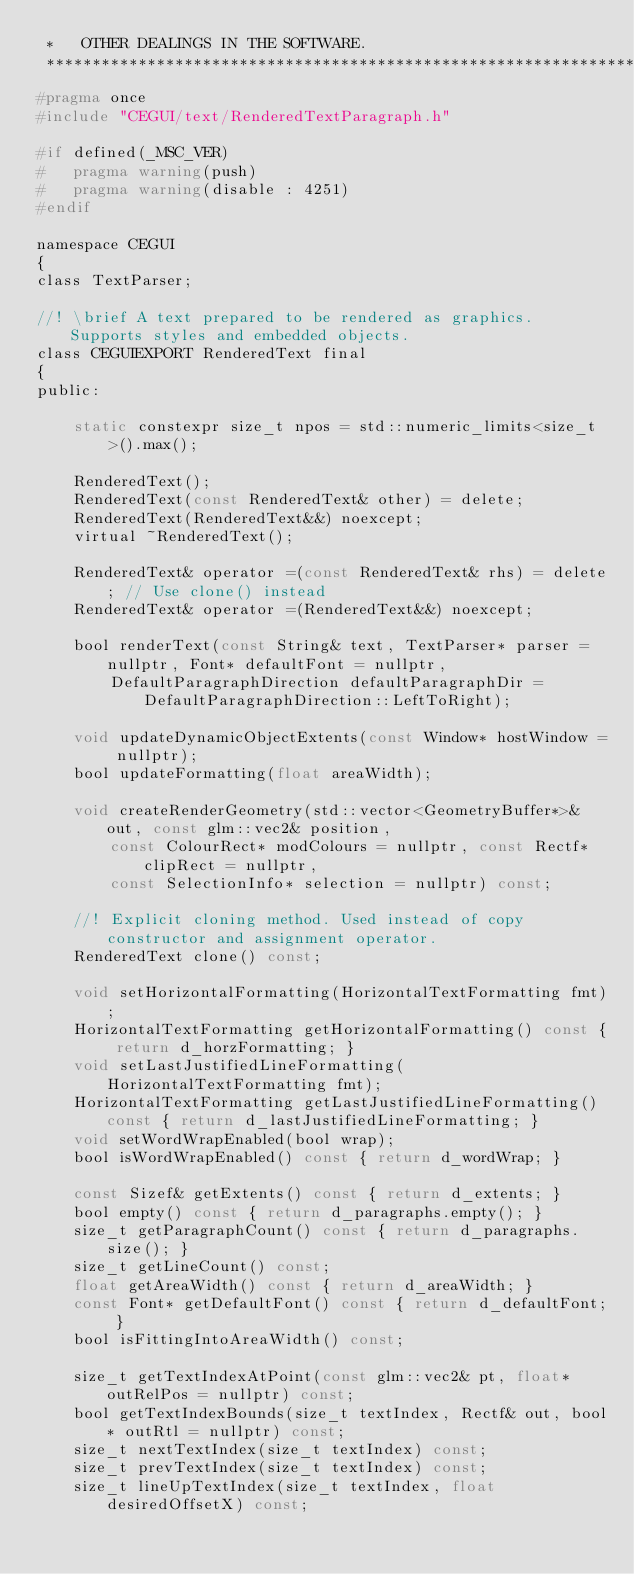<code> <loc_0><loc_0><loc_500><loc_500><_C_> *   OTHER DEALINGS IN THE SOFTWARE.
 ***************************************************************************/
#pragma once
#include "CEGUI/text/RenderedTextParagraph.h"

#if defined(_MSC_VER)
#   pragma warning(push)
#   pragma warning(disable : 4251)
#endif

namespace CEGUI
{
class TextParser;

//! \brief A text prepared to be rendered as graphics. Supports styles and embedded objects.
class CEGUIEXPORT RenderedText final
{
public:

    static constexpr size_t npos = std::numeric_limits<size_t>().max();

    RenderedText();
    RenderedText(const RenderedText& other) = delete;
    RenderedText(RenderedText&&) noexcept;
    virtual ~RenderedText();

    RenderedText& operator =(const RenderedText& rhs) = delete; // Use clone() instead
    RenderedText& operator =(RenderedText&&) noexcept;

    bool renderText(const String& text, TextParser* parser = nullptr, Font* defaultFont = nullptr,
        DefaultParagraphDirection defaultParagraphDir = DefaultParagraphDirection::LeftToRight);

    void updateDynamicObjectExtents(const Window* hostWindow = nullptr);
    bool updateFormatting(float areaWidth);

    void createRenderGeometry(std::vector<GeometryBuffer*>& out, const glm::vec2& position,
        const ColourRect* modColours = nullptr, const Rectf* clipRect = nullptr,
        const SelectionInfo* selection = nullptr) const;

    //! Explicit cloning method. Used instead of copy constructor and assignment operator.
    RenderedText clone() const;

    void setHorizontalFormatting(HorizontalTextFormatting fmt);
    HorizontalTextFormatting getHorizontalFormatting() const { return d_horzFormatting; }
    void setLastJustifiedLineFormatting(HorizontalTextFormatting fmt);
    HorizontalTextFormatting getLastJustifiedLineFormatting() const { return d_lastJustifiedLineFormatting; }
    void setWordWrapEnabled(bool wrap);
    bool isWordWrapEnabled() const { return d_wordWrap; }

    const Sizef& getExtents() const { return d_extents; }
    bool empty() const { return d_paragraphs.empty(); }
    size_t getParagraphCount() const { return d_paragraphs.size(); }
    size_t getLineCount() const;
    float getAreaWidth() const { return d_areaWidth; }
    const Font* getDefaultFont() const { return d_defaultFont; }
    bool isFittingIntoAreaWidth() const;

    size_t getTextIndexAtPoint(const glm::vec2& pt, float* outRelPos = nullptr) const;
    bool getTextIndexBounds(size_t textIndex, Rectf& out, bool* outRtl = nullptr) const;
    size_t nextTextIndex(size_t textIndex) const;
    size_t prevTextIndex(size_t textIndex) const;
    size_t lineUpTextIndex(size_t textIndex, float desiredOffsetX) const;</code> 